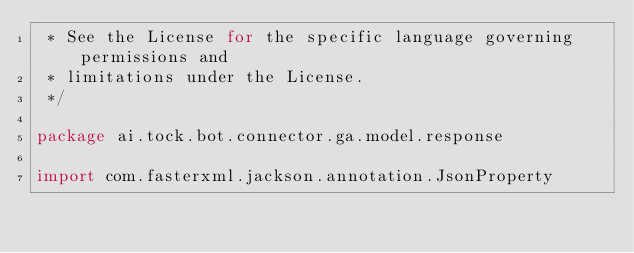Convert code to text. <code><loc_0><loc_0><loc_500><loc_500><_Kotlin_> * See the License for the specific language governing permissions and
 * limitations under the License.
 */

package ai.tock.bot.connector.ga.model.response

import com.fasterxml.jackson.annotation.JsonProperty</code> 